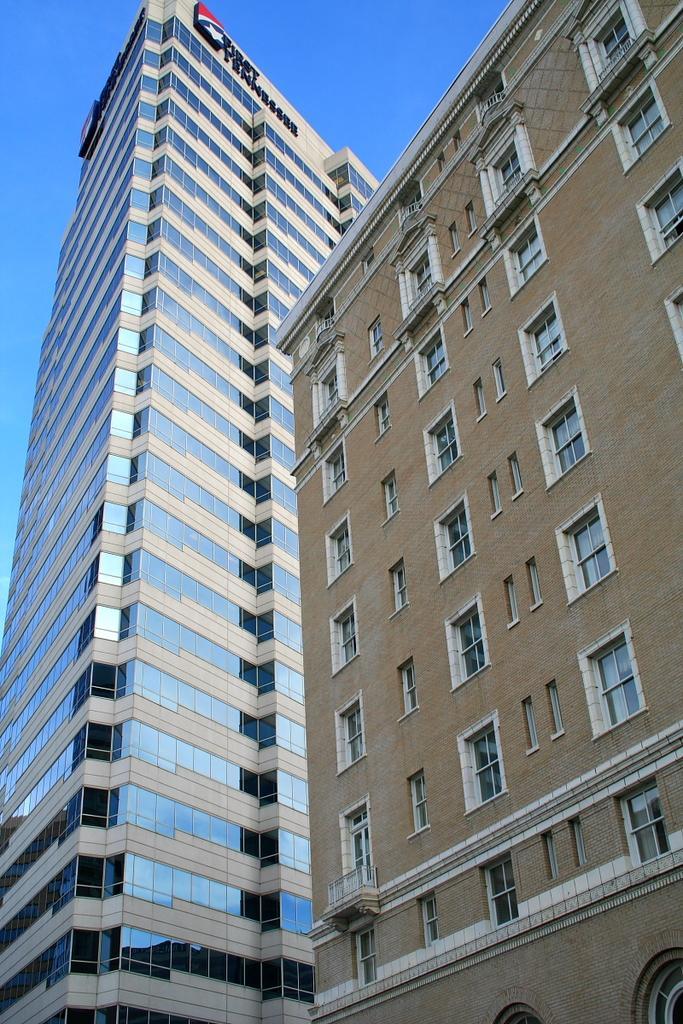Could you give a brief overview of what you see in this image? This picture is clicked outside the city. In this picture, we see buildings which are in brown and white color. On top of the building, we see some text written on it. At the top of the picture, we see the sky, which is blue in color. 